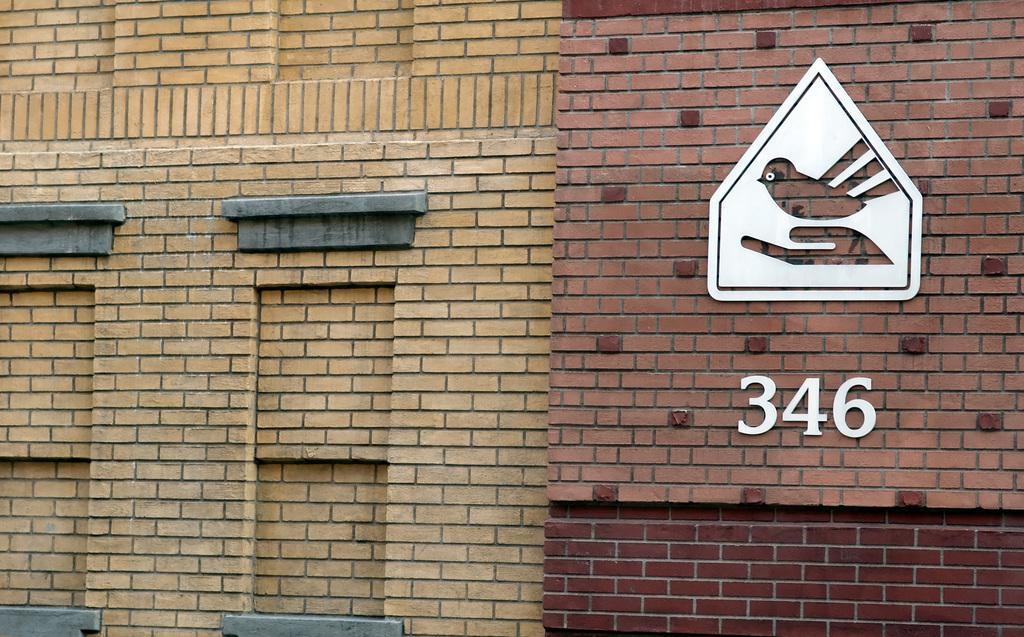Can you describe this image briefly? In this image there are walls of buildings. In the right on the wall there is a frame on it there is a structure of a bird. On the wall ¨346¨ is written. 